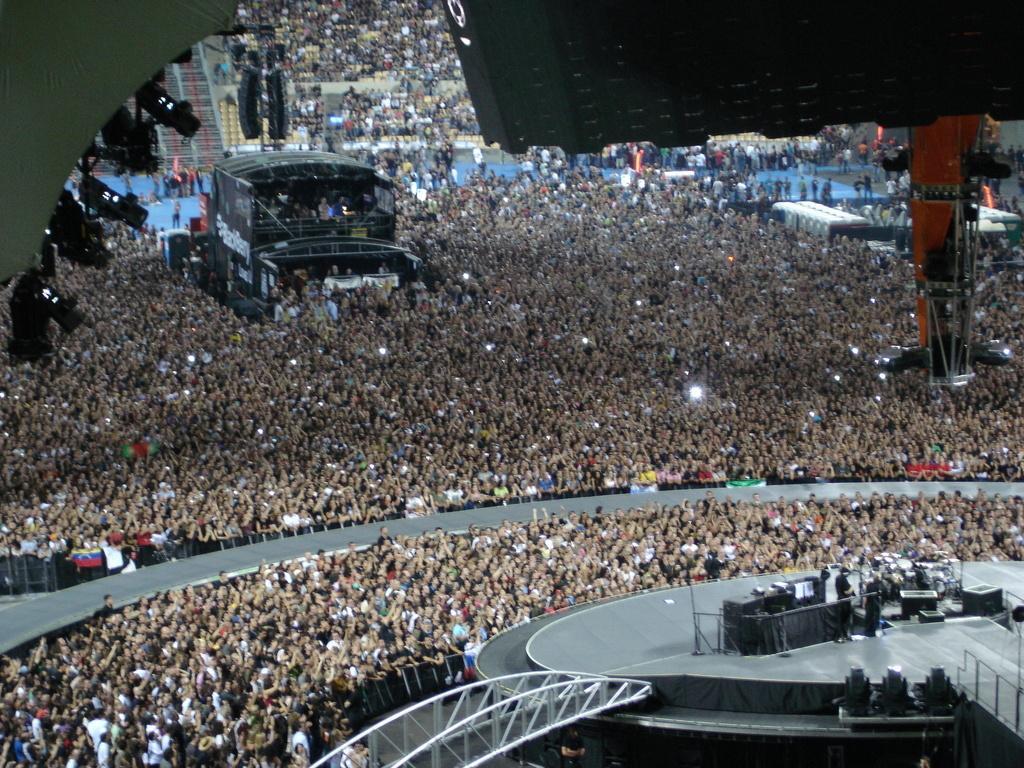Please provide a concise description of this image. This image might be taken at concert. At the bottom of the image we can see dais, lights and persons performing on dais. In the background there are lights, pillar and crowd. 